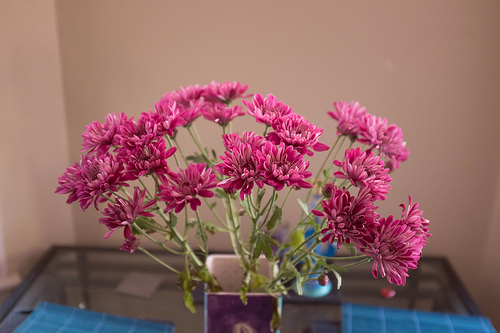<image>
Is the flowers next to the vase? No. The flowers is not positioned next to the vase. They are located in different areas of the scene. 